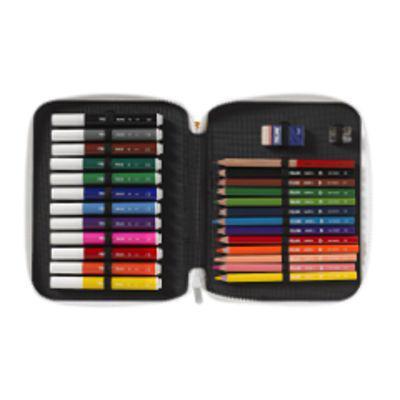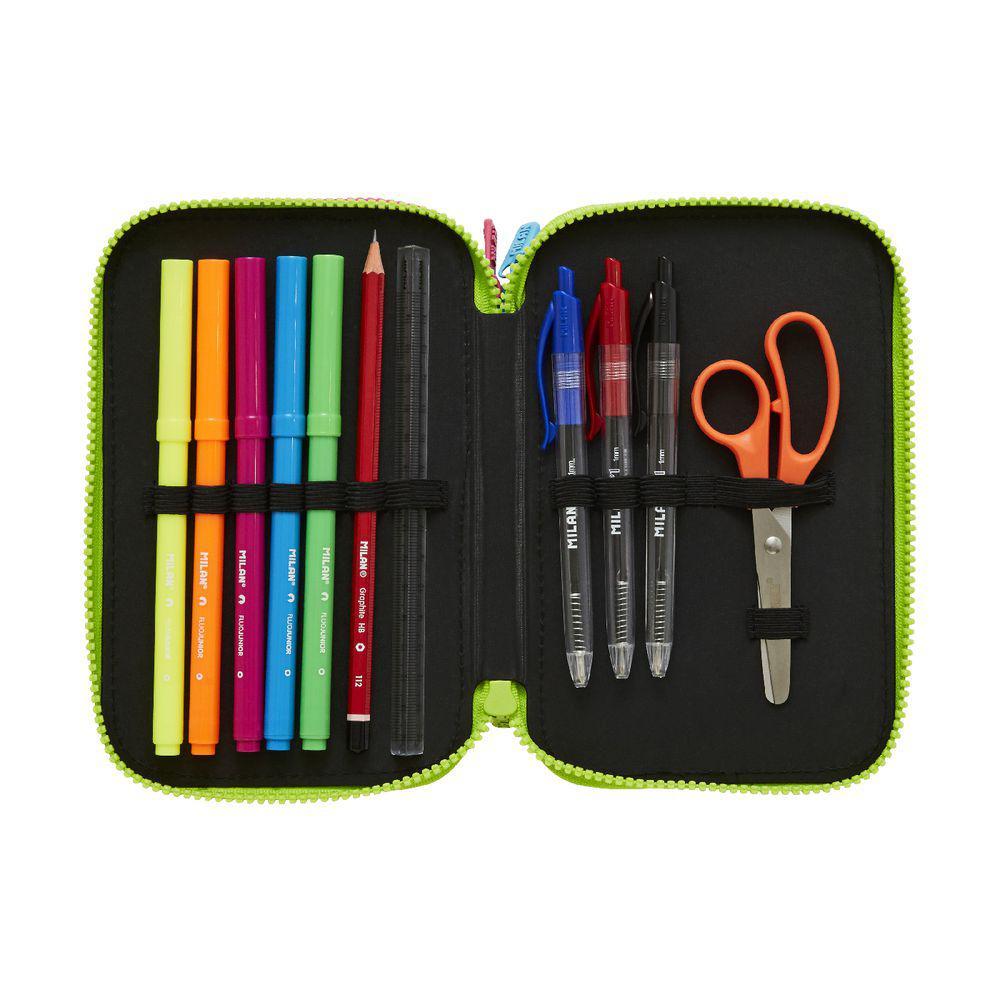The first image is the image on the left, the second image is the image on the right. Assess this claim about the two images: "The open, filled pencil case on the left has at least one inner compartment that fans out, while the filled case on the right has only a front and back and opens like a clamshell.". Correct or not? Answer yes or no. No. 